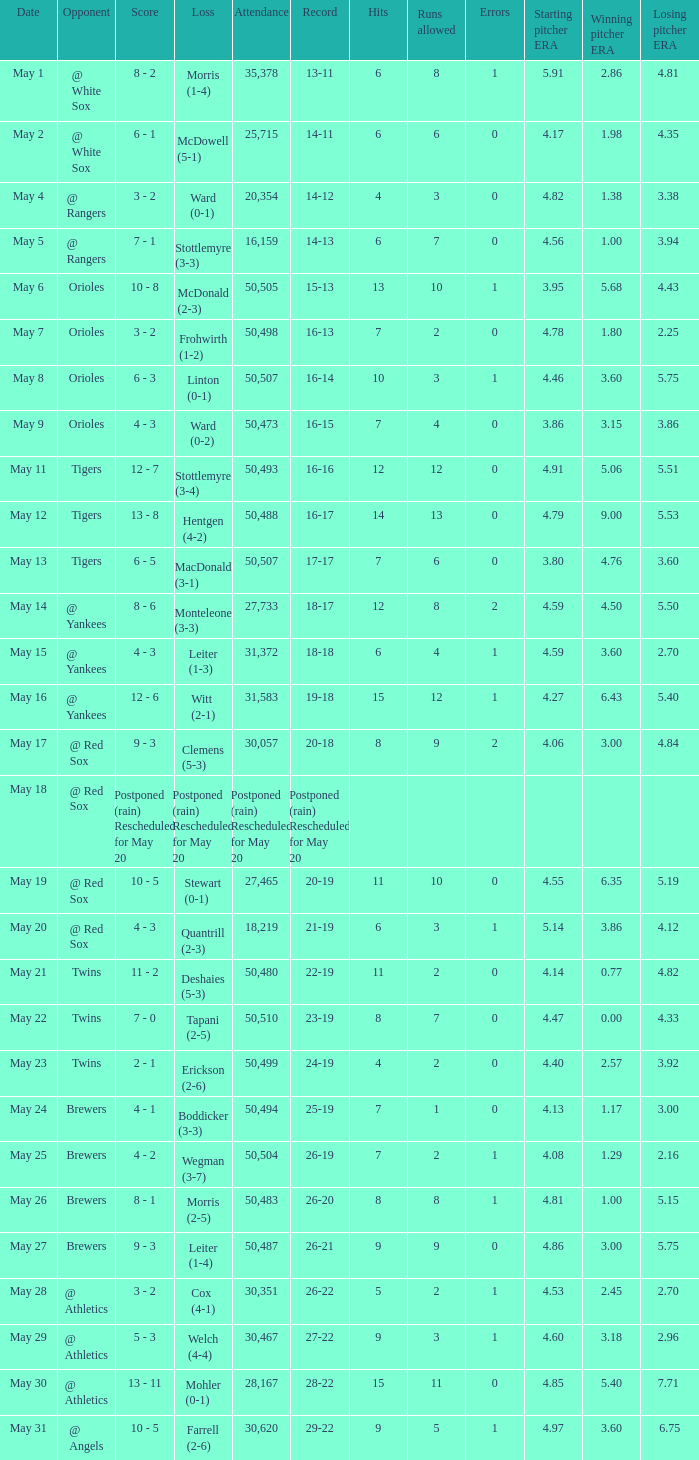On May 29 which team had the loss? Welch (4-4). 